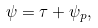Convert formula to latex. <formula><loc_0><loc_0><loc_500><loc_500>\psi = \tau + \psi _ { p } ,</formula> 